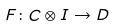Convert formula to latex. <formula><loc_0><loc_0><loc_500><loc_500>F \colon C \otimes I \to D</formula> 